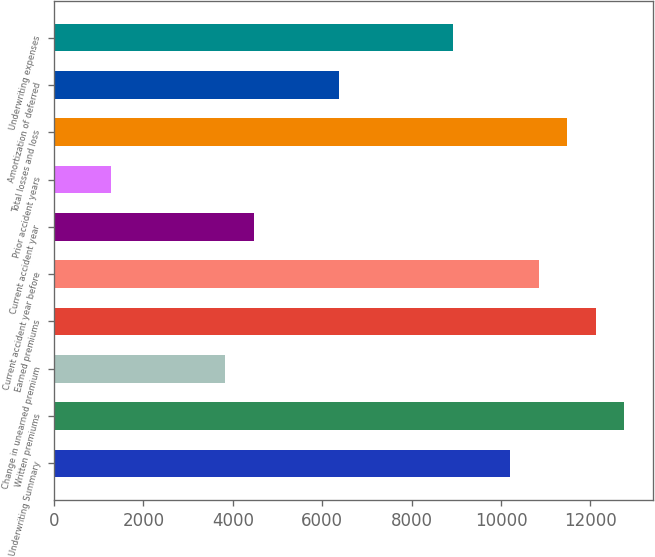Convert chart to OTSL. <chart><loc_0><loc_0><loc_500><loc_500><bar_chart><fcel>Underwriting Summary<fcel>Written premiums<fcel>Change in unearned premium<fcel>Earned premiums<fcel>Current accident year before<fcel>Current accident year<fcel>Prior accident years<fcel>Total losses and loss<fcel>Amortization of deferred<fcel>Underwriting expenses<nl><fcel>10207.8<fcel>12759<fcel>3829.8<fcel>12121.2<fcel>10845.6<fcel>4467.6<fcel>1278.6<fcel>11483.4<fcel>6381<fcel>8932.2<nl></chart> 